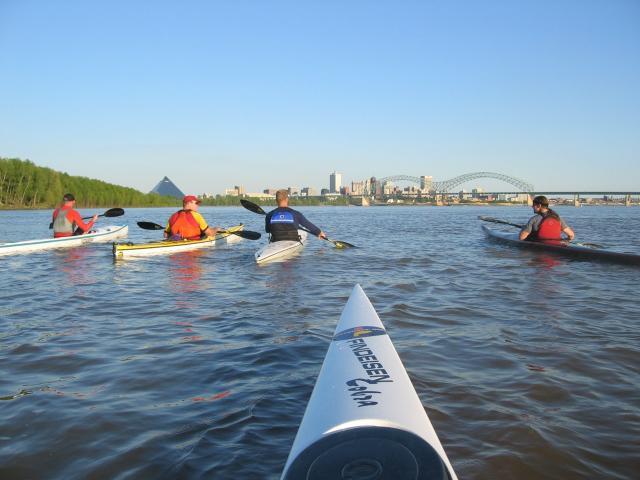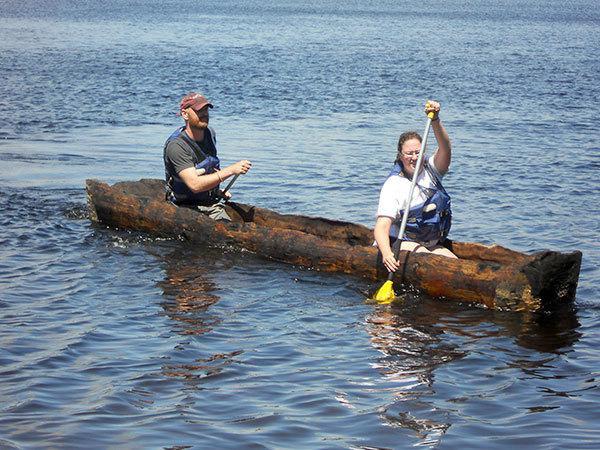The first image is the image on the left, the second image is the image on the right. Evaluate the accuracy of this statement regarding the images: "There is exactly one boat in the right image.". Is it true? Answer yes or no. Yes. 